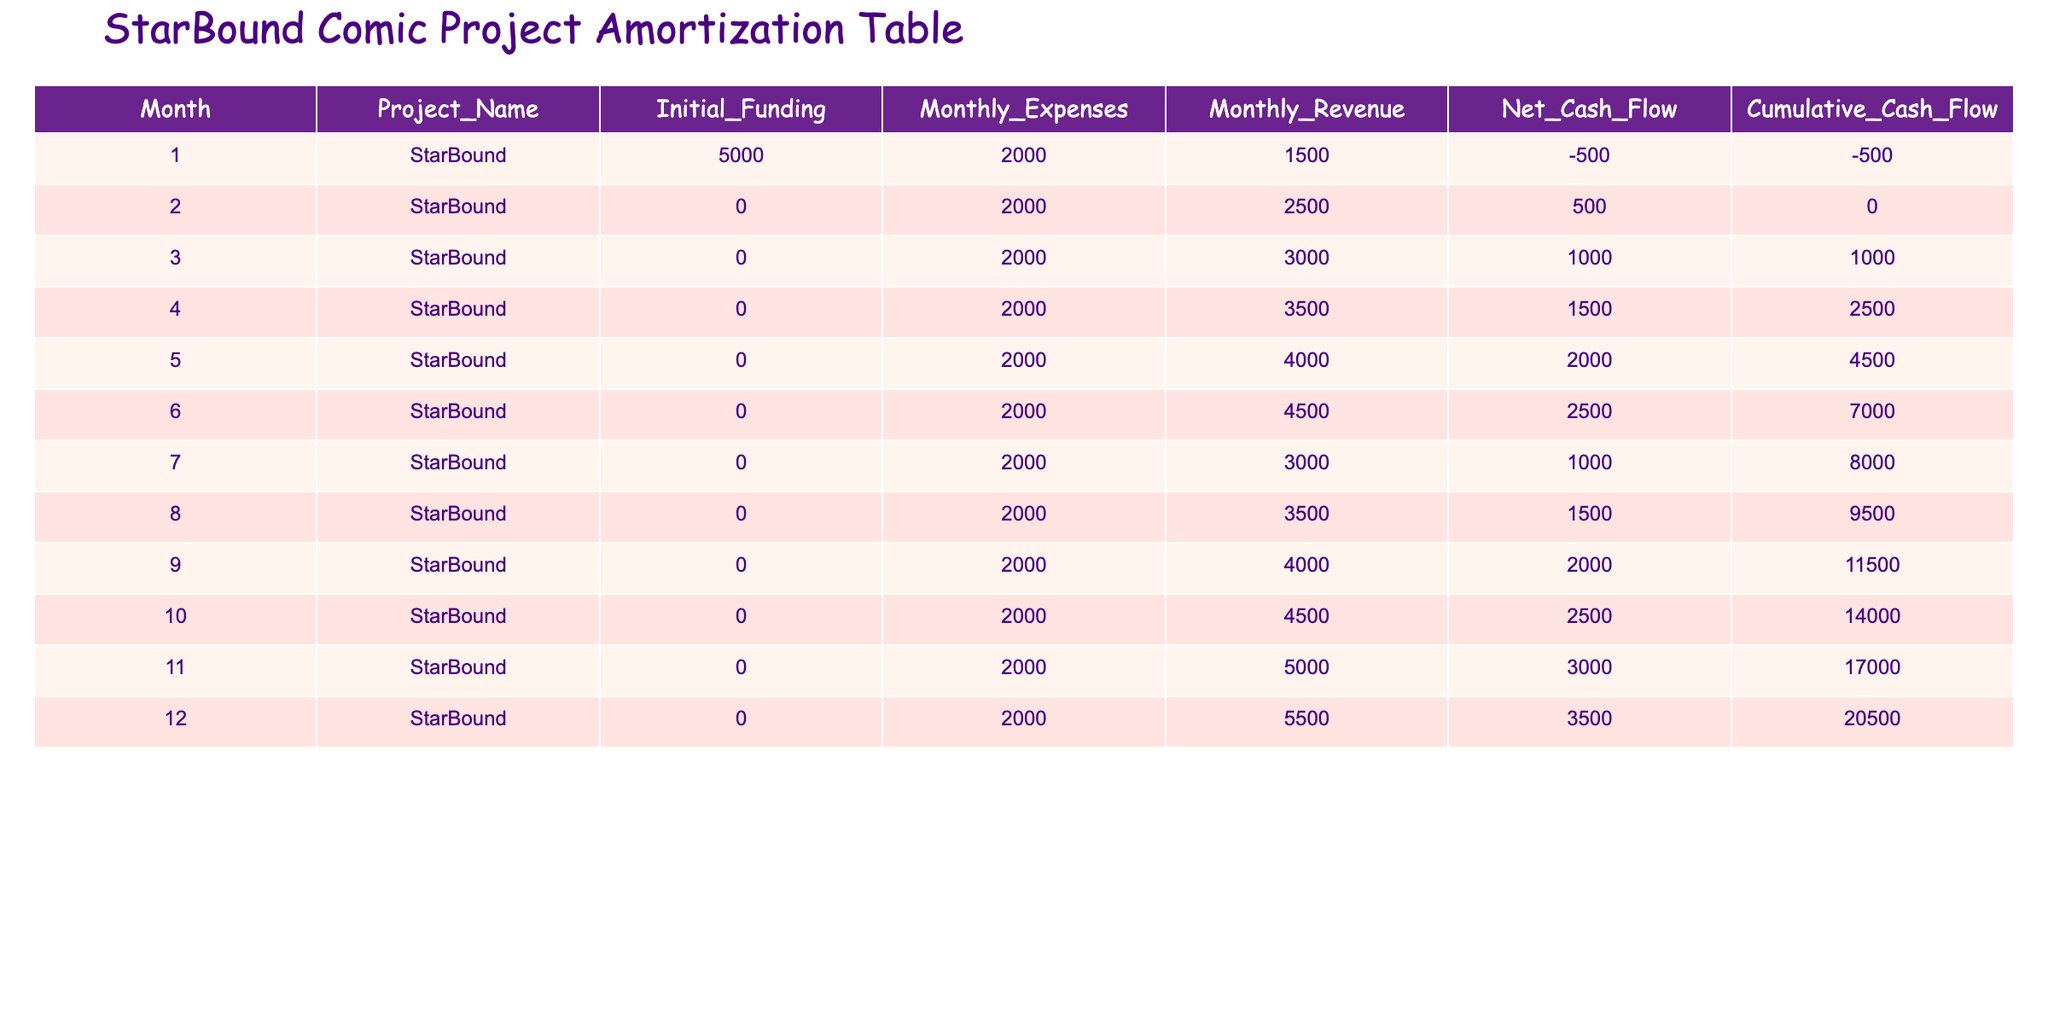What was the initial funding for the StarBound project? The initial funding for the StarBound project is listed in the first column of the table. For month 1, it shows 5000 dollars, which is the only initial funding mentioned for the project.
Answer: 5000 What was the net cash flow in month 5? The net cash flow for month 5 can be found in the table under the "Net Cash Flow" column corresponding to that month. It indicates a net cash flow of 2000 dollars.
Answer: 2000 How much did the cumulative cash flow increase from month 3 to month 10? To find the increase in cumulative cash flow from month 3 to month 10, we need to subtract the cumulative cash flow value in month 3 (1000 dollars) from the value in month 10 (14000 dollars). This gives us an increase of 13000 dollars (14000 - 1000 = 13000).
Answer: 13000 Was there any month where the monthly revenue was less than the monthly expenses? By examining the table, we see that in month 1, the monthly revenue (1500 dollars) was less than the monthly expenses (2000 dollars). This indicates that there was indeed a month where this occurred.
Answer: Yes In which month did the cumulative cash flow first exceed 10000 dollars? To determine when the cumulative cash flow first exceeded 10000 dollars, we look for the month where the cumulative cash flow values exceed 10000. According to the table, in month 10, it reached 14000 dollars, which is the first instance above 10000 dollars.
Answer: Month 10 What is the average monthly revenue over the entire year? To calculate the average monthly revenue, we first sum the monthly revenues from all months: 1500 + 2500 + 3000 + 3500 + 4000 + 4500 + 3000 + 3500 + 4000 + 4500 + 5000 + 5500 = 38500. Then, divide this total by 12 months, resulting in an average revenue of about 3208.33 dollars (38500/12 = 3208.33).
Answer: 3208.33 How much higher was the monthly revenue in month 12 compared to month 1? To find how much higher the monthly revenue in month 12 (5500 dollars) is compared to month 1 (1500 dollars), we subtract the revenue in month 1 from the revenue in month 12: 5500 - 1500 = 4000 dollars.
Answer: 4000 What was the total net cash flow for the entire project at the end of 12 months? The total net cash flow for the entire project can be found by looking at the "Net Cash Flow" column for the last month, which shows 3500 dollars. This is the total net cash flow for the project after 12 months.
Answer: 3500 